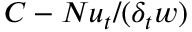<formula> <loc_0><loc_0><loc_500><loc_500>C - N u _ { t } / ( \delta _ { t } w )</formula> 